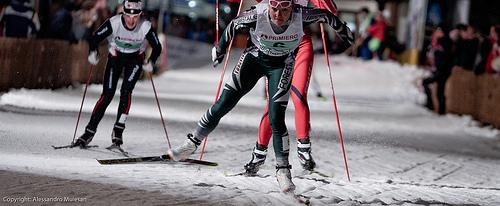Question: what time of year is it?
Choices:
A. Summer.
B. Spring.
C. Fall.
D. Winter.
Answer with the letter. Answer: D Question: how many racers are left?
Choices:
A. 8.
B. 7.
C. 2.
D. 3.
Answer with the letter. Answer: D Question: what protective gear is used?
Choices:
A. Helmet.
B. Gloves.
C. Eye goggles.
D. Vest.
Answer with the letter. Answer: C Question: when is the race taking place?
Choices:
A. During daylioght hours.
B. A dusk.
C. During dinner.
D. At night.
Answer with the letter. Answer: D 